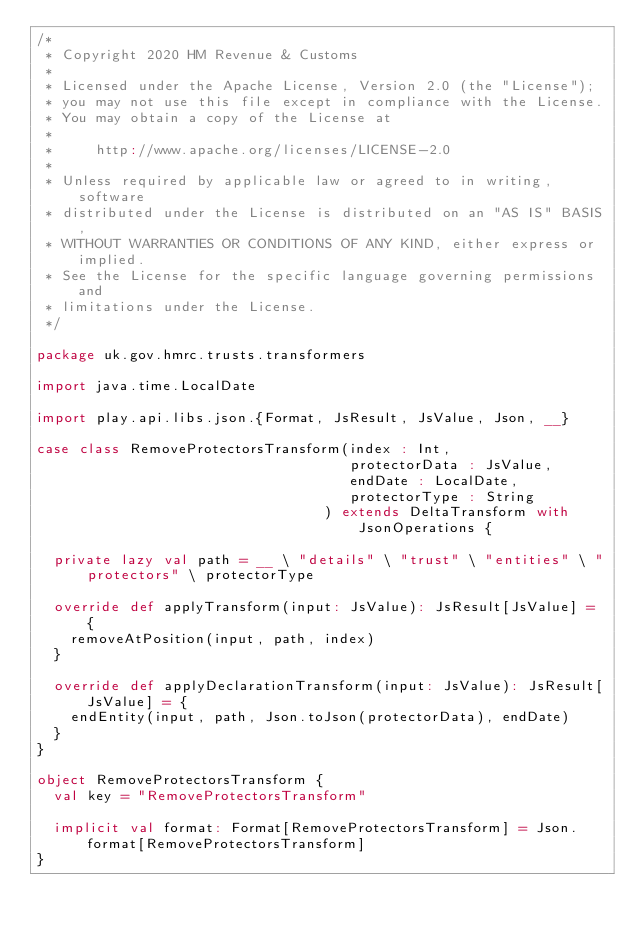<code> <loc_0><loc_0><loc_500><loc_500><_Scala_>/*
 * Copyright 2020 HM Revenue & Customs
 *
 * Licensed under the Apache License, Version 2.0 (the "License");
 * you may not use this file except in compliance with the License.
 * You may obtain a copy of the License at
 *
 *     http://www.apache.org/licenses/LICENSE-2.0
 *
 * Unless required by applicable law or agreed to in writing, software
 * distributed under the License is distributed on an "AS IS" BASIS,
 * WITHOUT WARRANTIES OR CONDITIONS OF ANY KIND, either express or implied.
 * See the License for the specific language governing permissions and
 * limitations under the License.
 */

package uk.gov.hmrc.trusts.transformers

import java.time.LocalDate

import play.api.libs.json.{Format, JsResult, JsValue, Json, __}

case class RemoveProtectorsTransform(index : Int,
                                     protectorData : JsValue,
                                     endDate : LocalDate,
                                     protectorType : String
                                  ) extends DeltaTransform with JsonOperations {

  private lazy val path = __ \ "details" \ "trust" \ "entities" \ "protectors" \ protectorType

  override def applyTransform(input: JsValue): JsResult[JsValue] = {
    removeAtPosition(input, path, index)
  }

  override def applyDeclarationTransform(input: JsValue): JsResult[JsValue] = {
    endEntity(input, path, Json.toJson(protectorData), endDate)
  }
}

object RemoveProtectorsTransform {
  val key = "RemoveProtectorsTransform"

  implicit val format: Format[RemoveProtectorsTransform] = Json.format[RemoveProtectorsTransform]
}</code> 